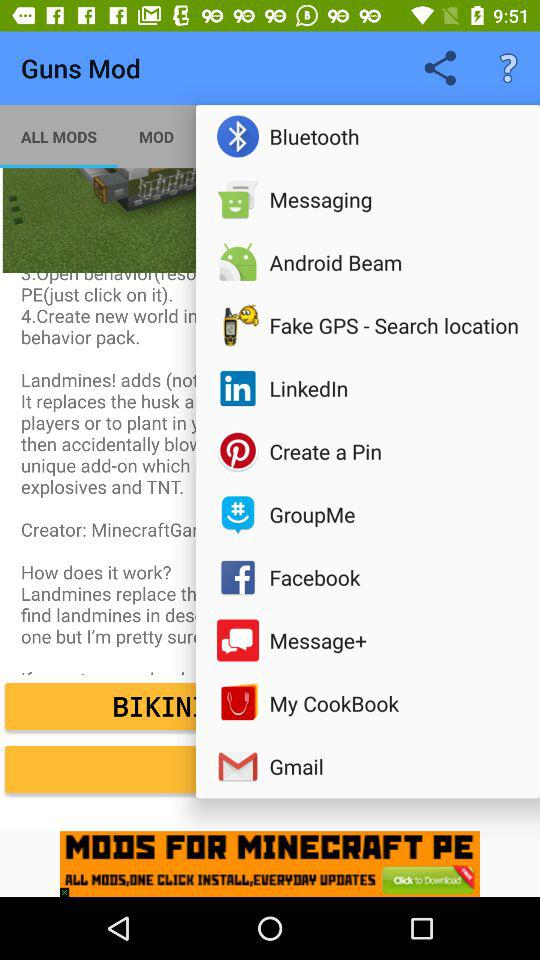Which option is selected for "Guns Mod"? The selected option is "ALL MODS". 